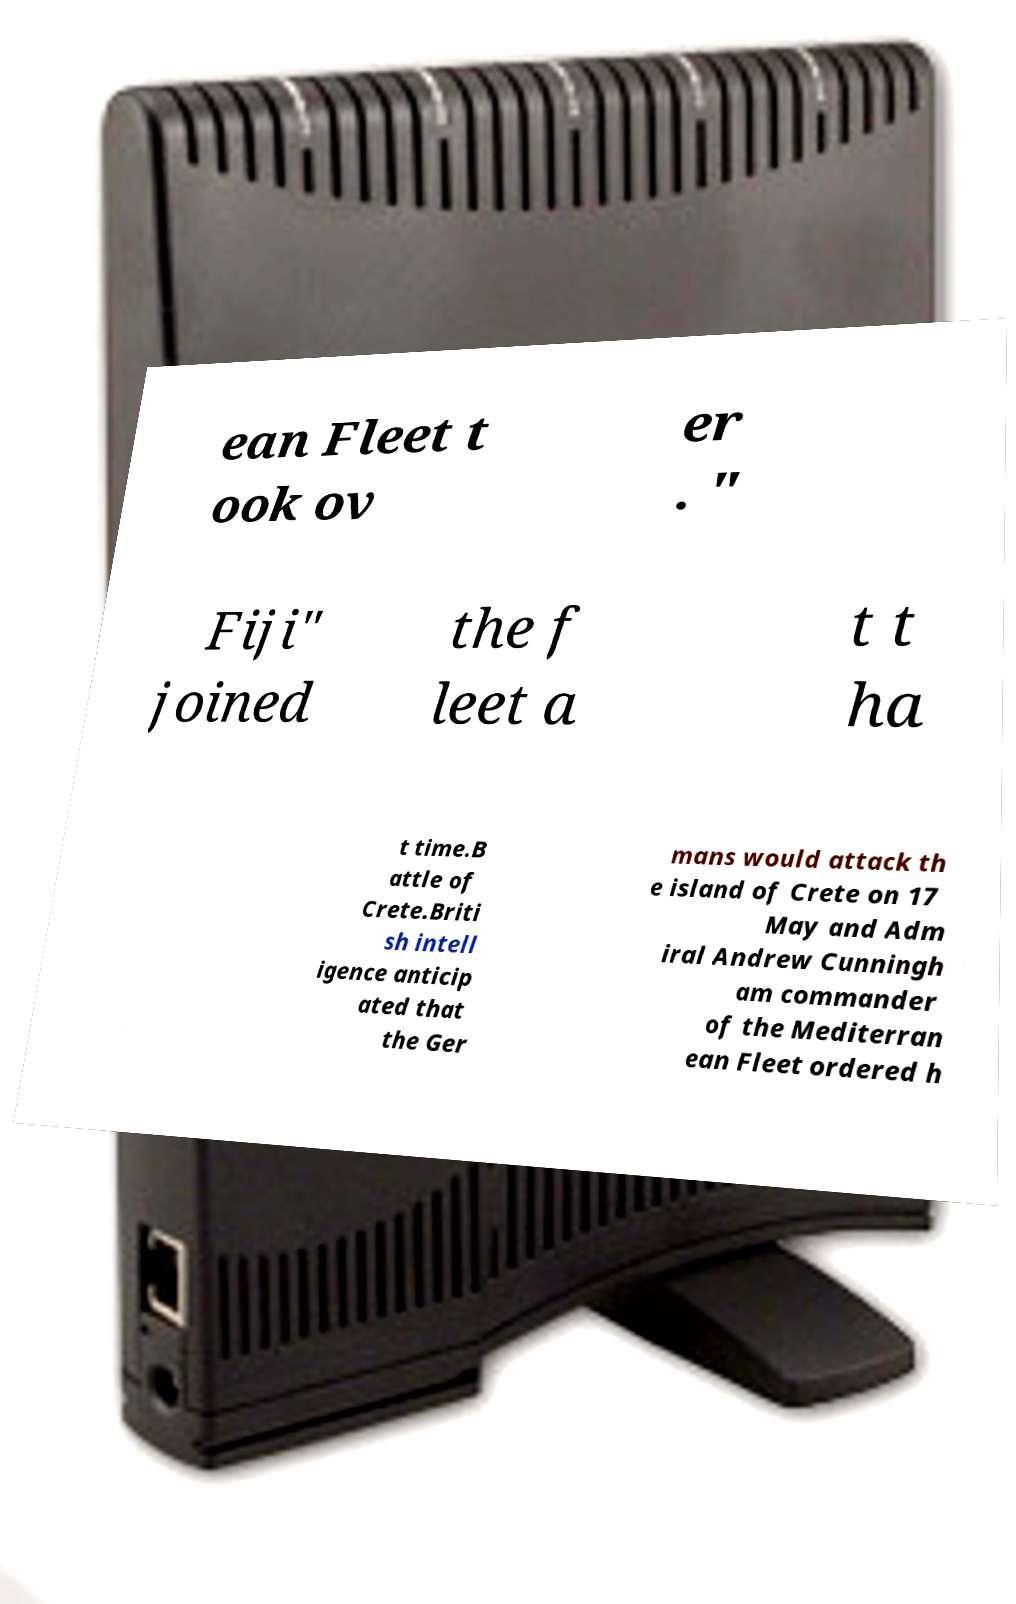Can you read and provide the text displayed in the image?This photo seems to have some interesting text. Can you extract and type it out for me? ean Fleet t ook ov er . " Fiji" joined the f leet a t t ha t time.B attle of Crete.Briti sh intell igence anticip ated that the Ger mans would attack th e island of Crete on 17 May and Adm iral Andrew Cunningh am commander of the Mediterran ean Fleet ordered h 